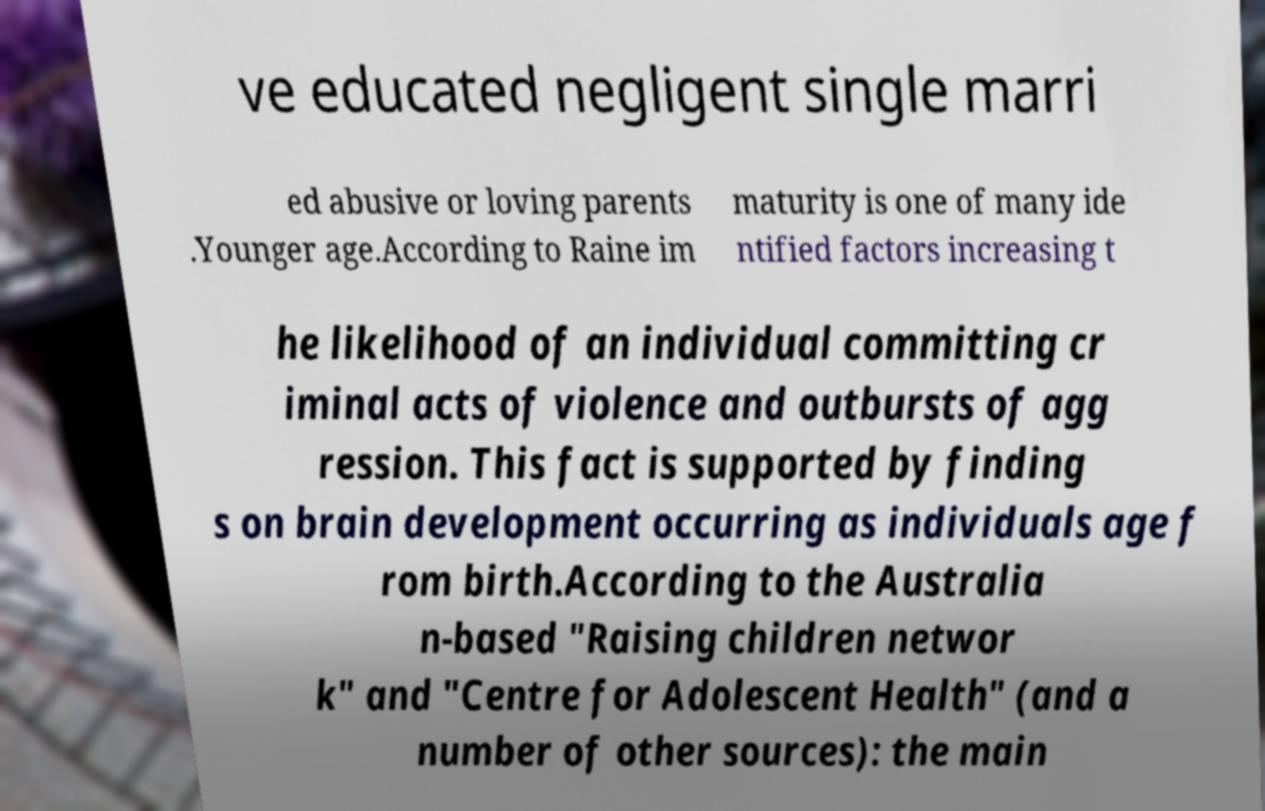I need the written content from this picture converted into text. Can you do that? ve educated negligent single marri ed abusive or loving parents .Younger age.According to Raine im maturity is one of many ide ntified factors increasing t he likelihood of an individual committing cr iminal acts of violence and outbursts of agg ression. This fact is supported by finding s on brain development occurring as individuals age f rom birth.According to the Australia n-based "Raising children networ k" and "Centre for Adolescent Health" (and a number of other sources): the main 